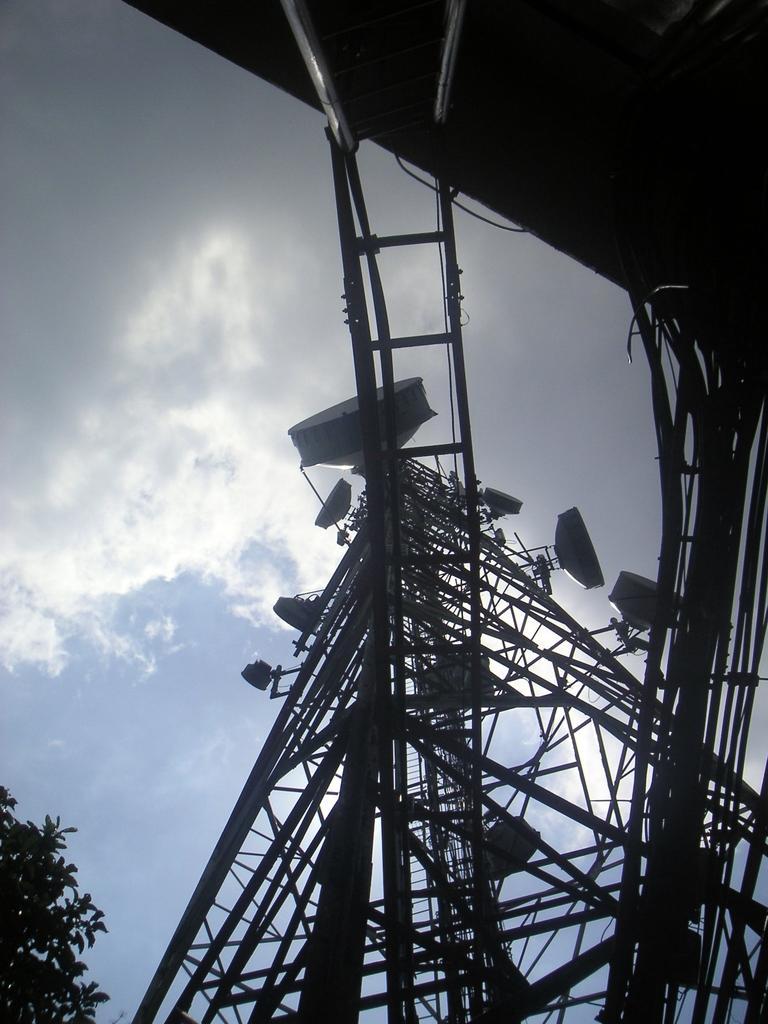How would you summarize this image in a sentence or two? In this image we can see electric tower, antennas, trees and sky with clouds. 